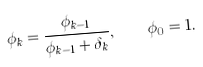Convert formula to latex. <formula><loc_0><loc_0><loc_500><loc_500>\phi _ { k } = \frac { \phi _ { k - 1 } } { \phi _ { k - 1 } + \delta _ { k } } , \quad \phi _ { 0 } = 1 .</formula> 